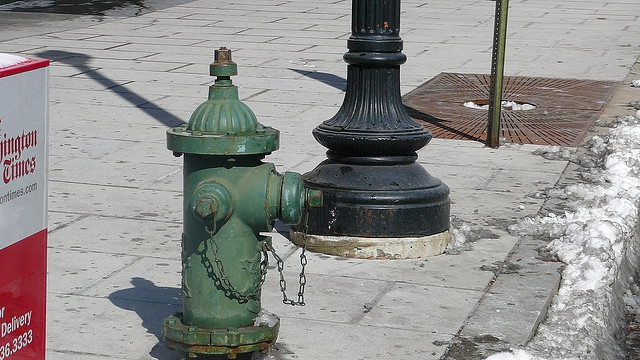Describe the objects in this image and their specific colors. I can see a fire hydrant in black, teal, and gray tones in this image. 